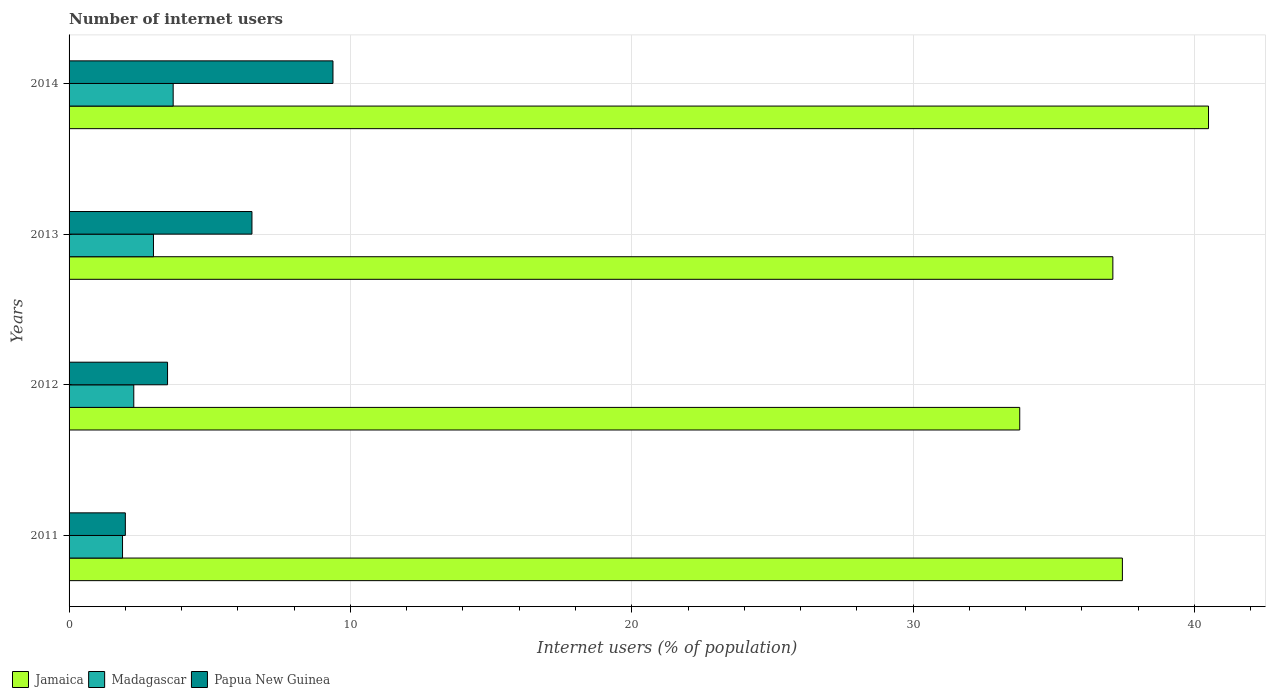How many groups of bars are there?
Make the answer very short. 4. Are the number of bars per tick equal to the number of legend labels?
Offer a terse response. Yes. Are the number of bars on each tick of the Y-axis equal?
Provide a short and direct response. Yes. How many bars are there on the 4th tick from the bottom?
Offer a very short reply. 3. In how many cases, is the number of bars for a given year not equal to the number of legend labels?
Provide a succinct answer. 0. Across all years, what is the maximum number of internet users in Madagascar?
Offer a terse response. 3.7. In which year was the number of internet users in Madagascar maximum?
Make the answer very short. 2014. What is the total number of internet users in Papua New Guinea in the graph?
Offer a very short reply. 21.38. What is the difference between the number of internet users in Papua New Guinea in 2012 and that in 2014?
Offer a very short reply. -5.88. What is the difference between the number of internet users in Papua New Guinea in 2014 and the number of internet users in Jamaica in 2012?
Offer a terse response. -24.41. What is the average number of internet users in Madagascar per year?
Your answer should be compact. 2.72. In the year 2014, what is the difference between the number of internet users in Jamaica and number of internet users in Papua New Guinea?
Provide a short and direct response. 31.12. In how many years, is the number of internet users in Madagascar greater than 34 %?
Provide a short and direct response. 0. What is the ratio of the number of internet users in Jamaica in 2011 to that in 2014?
Ensure brevity in your answer.  0.92. Is the difference between the number of internet users in Jamaica in 2011 and 2014 greater than the difference between the number of internet users in Papua New Guinea in 2011 and 2014?
Keep it short and to the point. Yes. What is the difference between the highest and the second highest number of internet users in Papua New Guinea?
Your response must be concise. 2.88. What is the difference between the highest and the lowest number of internet users in Madagascar?
Offer a very short reply. 1.8. Is the sum of the number of internet users in Jamaica in 2011 and 2012 greater than the maximum number of internet users in Madagascar across all years?
Offer a very short reply. Yes. What does the 1st bar from the top in 2014 represents?
Provide a succinct answer. Papua New Guinea. What does the 3rd bar from the bottom in 2013 represents?
Offer a terse response. Papua New Guinea. Is it the case that in every year, the sum of the number of internet users in Papua New Guinea and number of internet users in Madagascar is greater than the number of internet users in Jamaica?
Your answer should be very brief. No. How many bars are there?
Your answer should be very brief. 12. What is the difference between two consecutive major ticks on the X-axis?
Keep it short and to the point. 10. Does the graph contain any zero values?
Your answer should be very brief. No. Does the graph contain grids?
Keep it short and to the point. Yes. How many legend labels are there?
Ensure brevity in your answer.  3. What is the title of the graph?
Offer a very short reply. Number of internet users. What is the label or title of the X-axis?
Give a very brief answer. Internet users (% of population). What is the Internet users (% of population) in Jamaica in 2011?
Ensure brevity in your answer.  37.44. What is the Internet users (% of population) in Jamaica in 2012?
Keep it short and to the point. 33.79. What is the Internet users (% of population) of Papua New Guinea in 2012?
Provide a short and direct response. 3.5. What is the Internet users (% of population) in Jamaica in 2013?
Your answer should be very brief. 37.1. What is the Internet users (% of population) in Madagascar in 2013?
Offer a very short reply. 3. What is the Internet users (% of population) of Papua New Guinea in 2013?
Ensure brevity in your answer.  6.5. What is the Internet users (% of population) of Jamaica in 2014?
Keep it short and to the point. 40.5. What is the Internet users (% of population) in Papua New Guinea in 2014?
Keep it short and to the point. 9.38. Across all years, what is the maximum Internet users (% of population) in Jamaica?
Provide a short and direct response. 40.5. Across all years, what is the maximum Internet users (% of population) of Madagascar?
Your response must be concise. 3.7. Across all years, what is the maximum Internet users (% of population) of Papua New Guinea?
Keep it short and to the point. 9.38. Across all years, what is the minimum Internet users (% of population) in Jamaica?
Your answer should be compact. 33.79. What is the total Internet users (% of population) of Jamaica in the graph?
Ensure brevity in your answer.  148.83. What is the total Internet users (% of population) of Papua New Guinea in the graph?
Provide a succinct answer. 21.38. What is the difference between the Internet users (% of population) in Jamaica in 2011 and that in 2012?
Your answer should be very brief. 3.65. What is the difference between the Internet users (% of population) of Madagascar in 2011 and that in 2012?
Give a very brief answer. -0.4. What is the difference between the Internet users (% of population) of Papua New Guinea in 2011 and that in 2012?
Offer a terse response. -1.5. What is the difference between the Internet users (% of population) in Jamaica in 2011 and that in 2013?
Keep it short and to the point. 0.34. What is the difference between the Internet users (% of population) in Madagascar in 2011 and that in 2013?
Make the answer very short. -1.1. What is the difference between the Internet users (% of population) of Papua New Guinea in 2011 and that in 2013?
Provide a succinct answer. -4.5. What is the difference between the Internet users (% of population) of Jamaica in 2011 and that in 2014?
Provide a succinct answer. -3.06. What is the difference between the Internet users (% of population) of Papua New Guinea in 2011 and that in 2014?
Offer a very short reply. -7.38. What is the difference between the Internet users (% of population) of Jamaica in 2012 and that in 2013?
Your answer should be very brief. -3.31. What is the difference between the Internet users (% of population) in Madagascar in 2012 and that in 2013?
Keep it short and to the point. -0.7. What is the difference between the Internet users (% of population) of Papua New Guinea in 2012 and that in 2013?
Your answer should be very brief. -3. What is the difference between the Internet users (% of population) in Jamaica in 2012 and that in 2014?
Your response must be concise. -6.71. What is the difference between the Internet users (% of population) of Madagascar in 2012 and that in 2014?
Make the answer very short. -1.4. What is the difference between the Internet users (% of population) in Papua New Guinea in 2012 and that in 2014?
Your answer should be very brief. -5.88. What is the difference between the Internet users (% of population) of Jamaica in 2013 and that in 2014?
Your answer should be compact. -3.4. What is the difference between the Internet users (% of population) in Papua New Guinea in 2013 and that in 2014?
Offer a terse response. -2.88. What is the difference between the Internet users (% of population) of Jamaica in 2011 and the Internet users (% of population) of Madagascar in 2012?
Keep it short and to the point. 35.14. What is the difference between the Internet users (% of population) of Jamaica in 2011 and the Internet users (% of population) of Papua New Guinea in 2012?
Your response must be concise. 33.94. What is the difference between the Internet users (% of population) of Jamaica in 2011 and the Internet users (% of population) of Madagascar in 2013?
Keep it short and to the point. 34.44. What is the difference between the Internet users (% of population) in Jamaica in 2011 and the Internet users (% of population) in Papua New Guinea in 2013?
Offer a very short reply. 30.94. What is the difference between the Internet users (% of population) in Madagascar in 2011 and the Internet users (% of population) in Papua New Guinea in 2013?
Your response must be concise. -4.6. What is the difference between the Internet users (% of population) in Jamaica in 2011 and the Internet users (% of population) in Madagascar in 2014?
Your answer should be compact. 33.74. What is the difference between the Internet users (% of population) in Jamaica in 2011 and the Internet users (% of population) in Papua New Guinea in 2014?
Provide a short and direct response. 28.06. What is the difference between the Internet users (% of population) in Madagascar in 2011 and the Internet users (% of population) in Papua New Guinea in 2014?
Your answer should be very brief. -7.48. What is the difference between the Internet users (% of population) in Jamaica in 2012 and the Internet users (% of population) in Madagascar in 2013?
Offer a terse response. 30.79. What is the difference between the Internet users (% of population) in Jamaica in 2012 and the Internet users (% of population) in Papua New Guinea in 2013?
Ensure brevity in your answer.  27.29. What is the difference between the Internet users (% of population) in Jamaica in 2012 and the Internet users (% of population) in Madagascar in 2014?
Ensure brevity in your answer.  30.09. What is the difference between the Internet users (% of population) of Jamaica in 2012 and the Internet users (% of population) of Papua New Guinea in 2014?
Provide a short and direct response. 24.41. What is the difference between the Internet users (% of population) of Madagascar in 2012 and the Internet users (% of population) of Papua New Guinea in 2014?
Provide a succinct answer. -7.08. What is the difference between the Internet users (% of population) in Jamaica in 2013 and the Internet users (% of population) in Madagascar in 2014?
Provide a short and direct response. 33.4. What is the difference between the Internet users (% of population) in Jamaica in 2013 and the Internet users (% of population) in Papua New Guinea in 2014?
Provide a succinct answer. 27.72. What is the difference between the Internet users (% of population) in Madagascar in 2013 and the Internet users (% of population) in Papua New Guinea in 2014?
Make the answer very short. -6.38. What is the average Internet users (% of population) in Jamaica per year?
Your answer should be compact. 37.21. What is the average Internet users (% of population) of Madagascar per year?
Provide a short and direct response. 2.73. What is the average Internet users (% of population) in Papua New Guinea per year?
Offer a very short reply. 5.34. In the year 2011, what is the difference between the Internet users (% of population) in Jamaica and Internet users (% of population) in Madagascar?
Your answer should be compact. 35.54. In the year 2011, what is the difference between the Internet users (% of population) of Jamaica and Internet users (% of population) of Papua New Guinea?
Provide a short and direct response. 35.44. In the year 2012, what is the difference between the Internet users (% of population) of Jamaica and Internet users (% of population) of Madagascar?
Your response must be concise. 31.49. In the year 2012, what is the difference between the Internet users (% of population) of Jamaica and Internet users (% of population) of Papua New Guinea?
Offer a very short reply. 30.29. In the year 2013, what is the difference between the Internet users (% of population) in Jamaica and Internet users (% of population) in Madagascar?
Offer a very short reply. 34.1. In the year 2013, what is the difference between the Internet users (% of population) in Jamaica and Internet users (% of population) in Papua New Guinea?
Offer a very short reply. 30.6. In the year 2014, what is the difference between the Internet users (% of population) of Jamaica and Internet users (% of population) of Madagascar?
Provide a succinct answer. 36.8. In the year 2014, what is the difference between the Internet users (% of population) of Jamaica and Internet users (% of population) of Papua New Guinea?
Ensure brevity in your answer.  31.12. In the year 2014, what is the difference between the Internet users (% of population) in Madagascar and Internet users (% of population) in Papua New Guinea?
Offer a very short reply. -5.68. What is the ratio of the Internet users (% of population) in Jamaica in 2011 to that in 2012?
Your answer should be very brief. 1.11. What is the ratio of the Internet users (% of population) of Madagascar in 2011 to that in 2012?
Ensure brevity in your answer.  0.83. What is the ratio of the Internet users (% of population) of Jamaica in 2011 to that in 2013?
Make the answer very short. 1.01. What is the ratio of the Internet users (% of population) of Madagascar in 2011 to that in 2013?
Ensure brevity in your answer.  0.63. What is the ratio of the Internet users (% of population) of Papua New Guinea in 2011 to that in 2013?
Ensure brevity in your answer.  0.31. What is the ratio of the Internet users (% of population) of Jamaica in 2011 to that in 2014?
Keep it short and to the point. 0.92. What is the ratio of the Internet users (% of population) in Madagascar in 2011 to that in 2014?
Provide a short and direct response. 0.51. What is the ratio of the Internet users (% of population) of Papua New Guinea in 2011 to that in 2014?
Provide a short and direct response. 0.21. What is the ratio of the Internet users (% of population) of Jamaica in 2012 to that in 2013?
Your response must be concise. 0.91. What is the ratio of the Internet users (% of population) of Madagascar in 2012 to that in 2013?
Make the answer very short. 0.77. What is the ratio of the Internet users (% of population) of Papua New Guinea in 2012 to that in 2013?
Make the answer very short. 0.54. What is the ratio of the Internet users (% of population) in Jamaica in 2012 to that in 2014?
Keep it short and to the point. 0.83. What is the ratio of the Internet users (% of population) of Madagascar in 2012 to that in 2014?
Your answer should be very brief. 0.62. What is the ratio of the Internet users (% of population) in Papua New Guinea in 2012 to that in 2014?
Your answer should be very brief. 0.37. What is the ratio of the Internet users (% of population) of Jamaica in 2013 to that in 2014?
Provide a short and direct response. 0.92. What is the ratio of the Internet users (% of population) of Madagascar in 2013 to that in 2014?
Make the answer very short. 0.81. What is the ratio of the Internet users (% of population) of Papua New Guinea in 2013 to that in 2014?
Your response must be concise. 0.69. What is the difference between the highest and the second highest Internet users (% of population) in Jamaica?
Offer a terse response. 3.06. What is the difference between the highest and the second highest Internet users (% of population) of Papua New Guinea?
Your response must be concise. 2.88. What is the difference between the highest and the lowest Internet users (% of population) in Jamaica?
Your answer should be compact. 6.71. What is the difference between the highest and the lowest Internet users (% of population) of Papua New Guinea?
Make the answer very short. 7.38. 